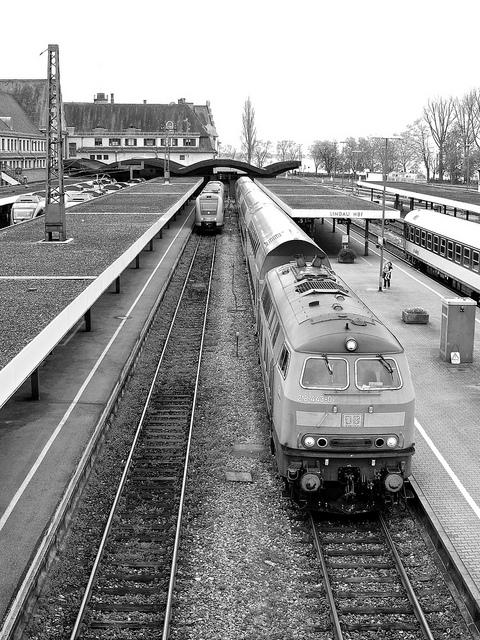Are the tracks wooden?
Give a very brief answer. No. Are there mountains?
Quick response, please. No. What color is the train?
Keep it brief. Gray. Is there a large group of people waiting for the train?
Concise answer only. No. How many trains are in the yard?
Write a very short answer. 2. Are these trains moving in the same direction?
Write a very short answer. Yes. 